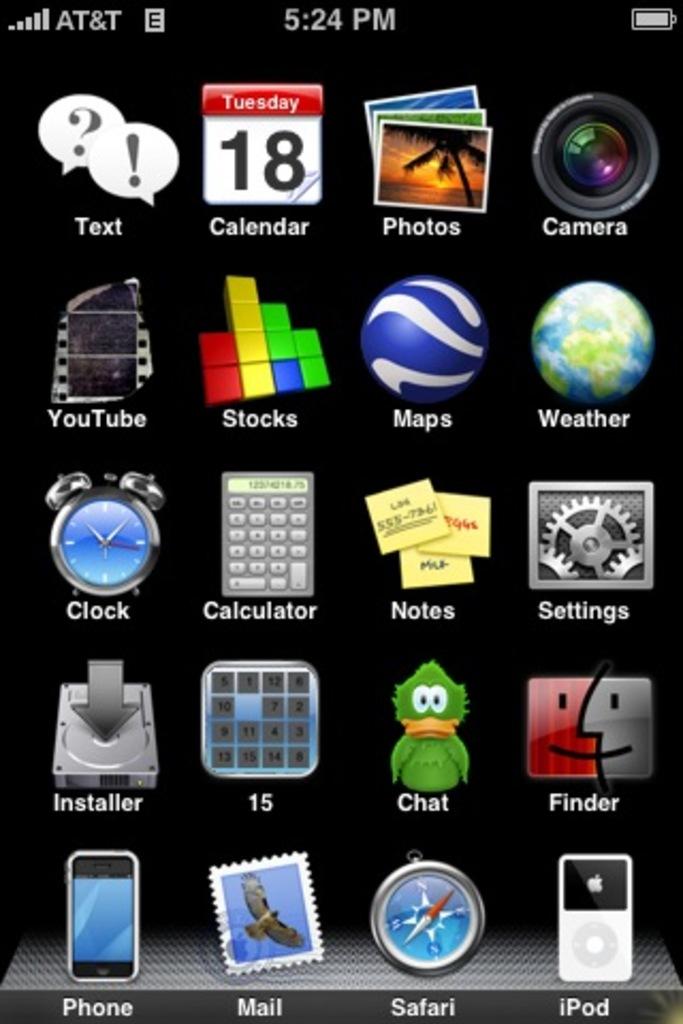What day is on the calendar?
Offer a very short reply. 18. What is the day of the week shown on the phone?
Provide a short and direct response. Tuesday. 